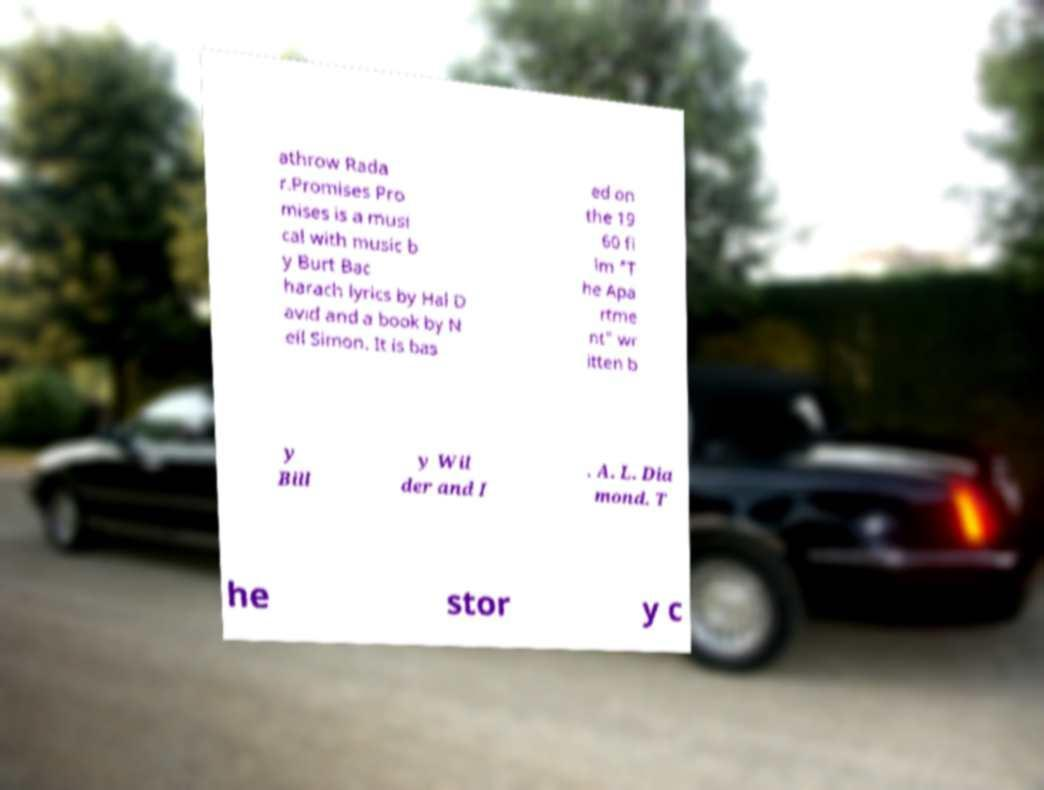For documentation purposes, I need the text within this image transcribed. Could you provide that? athrow Rada r.Promises Pro mises is a musi cal with music b y Burt Bac harach lyrics by Hal D avid and a book by N eil Simon. It is bas ed on the 19 60 fi lm "T he Apa rtme nt" wr itten b y Bill y Wil der and I . A. L. Dia mond. T he stor y c 